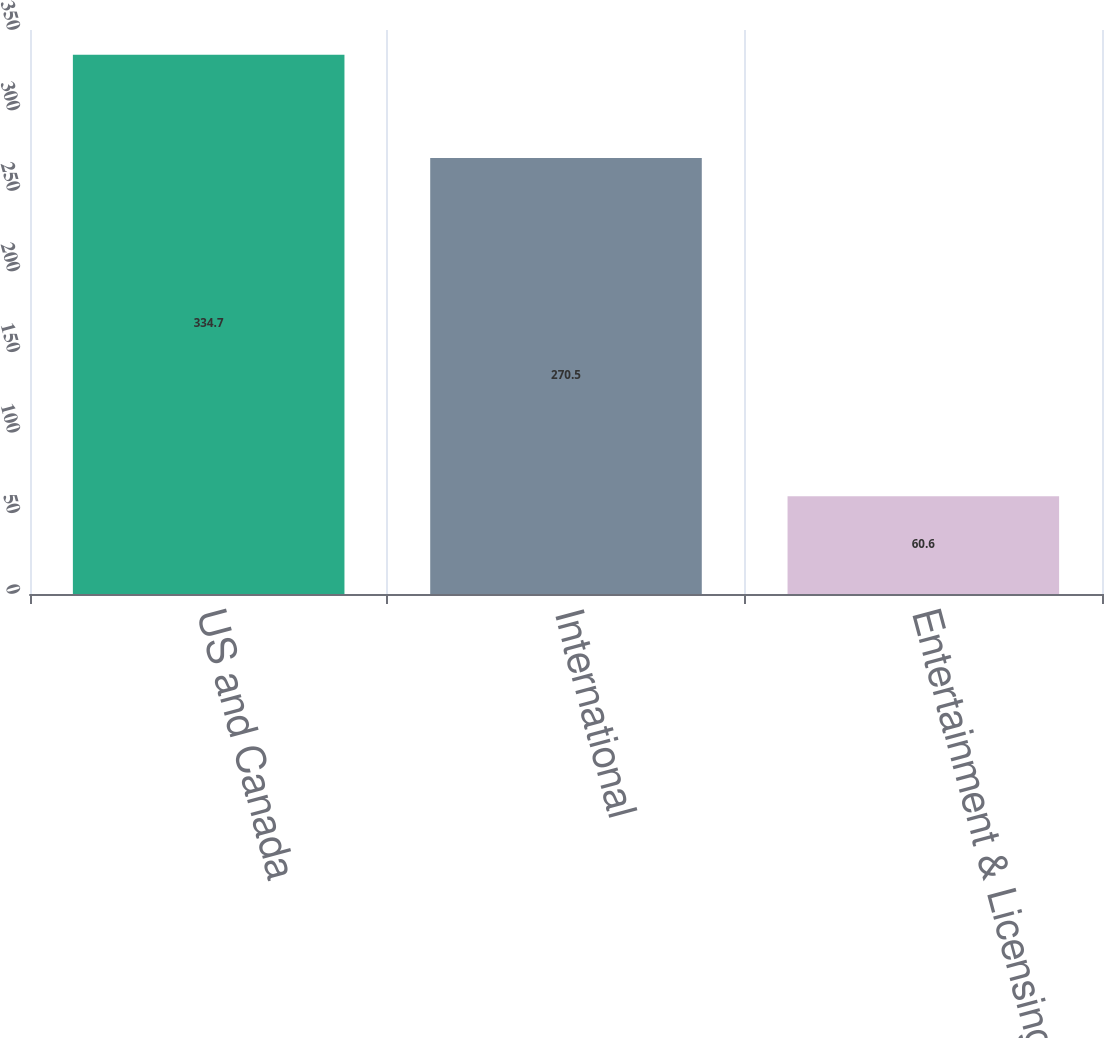Convert chart to OTSL. <chart><loc_0><loc_0><loc_500><loc_500><bar_chart><fcel>US and Canada<fcel>International<fcel>Entertainment & Licensing<nl><fcel>334.7<fcel>270.5<fcel>60.6<nl></chart> 